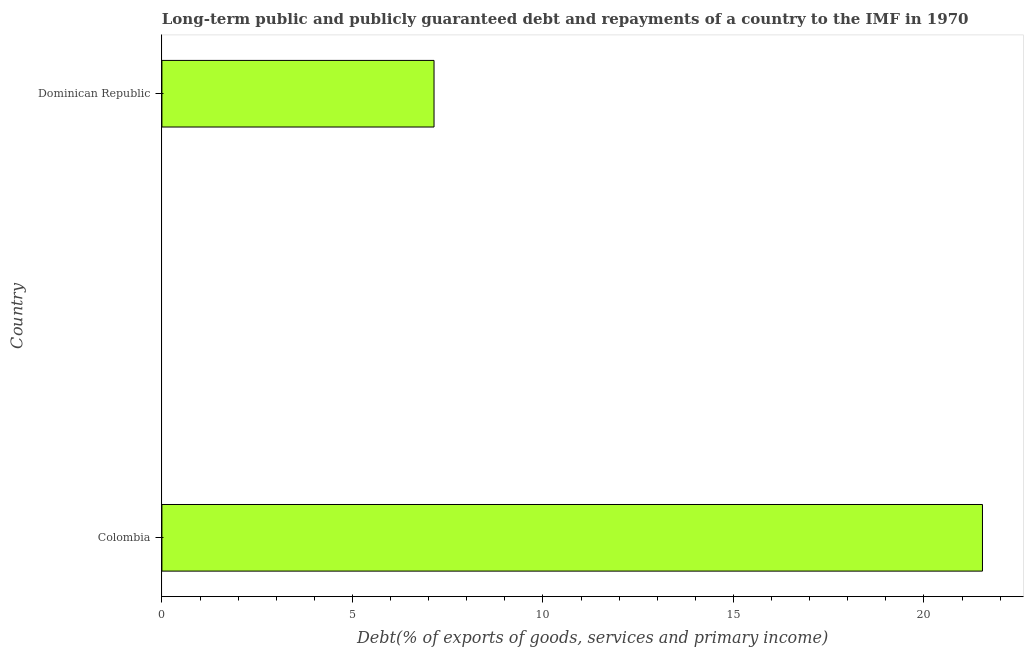What is the title of the graph?
Provide a short and direct response. Long-term public and publicly guaranteed debt and repayments of a country to the IMF in 1970. What is the label or title of the X-axis?
Give a very brief answer. Debt(% of exports of goods, services and primary income). What is the debt service in Colombia?
Keep it short and to the point. 21.53. Across all countries, what is the maximum debt service?
Your answer should be very brief. 21.53. Across all countries, what is the minimum debt service?
Provide a short and direct response. 7.14. In which country was the debt service maximum?
Your answer should be compact. Colombia. In which country was the debt service minimum?
Provide a short and direct response. Dominican Republic. What is the sum of the debt service?
Your response must be concise. 28.68. What is the difference between the debt service in Colombia and Dominican Republic?
Give a very brief answer. 14.39. What is the average debt service per country?
Your response must be concise. 14.34. What is the median debt service?
Provide a short and direct response. 14.34. What is the ratio of the debt service in Colombia to that in Dominican Republic?
Provide a succinct answer. 3.02. Is the debt service in Colombia less than that in Dominican Republic?
Ensure brevity in your answer.  No. In how many countries, is the debt service greater than the average debt service taken over all countries?
Your answer should be compact. 1. How many bars are there?
Your response must be concise. 2. Are all the bars in the graph horizontal?
Keep it short and to the point. Yes. What is the difference between two consecutive major ticks on the X-axis?
Offer a terse response. 5. Are the values on the major ticks of X-axis written in scientific E-notation?
Your answer should be very brief. No. What is the Debt(% of exports of goods, services and primary income) of Colombia?
Give a very brief answer. 21.53. What is the Debt(% of exports of goods, services and primary income) of Dominican Republic?
Provide a short and direct response. 7.14. What is the difference between the Debt(% of exports of goods, services and primary income) in Colombia and Dominican Republic?
Provide a succinct answer. 14.39. What is the ratio of the Debt(% of exports of goods, services and primary income) in Colombia to that in Dominican Republic?
Offer a terse response. 3.02. 